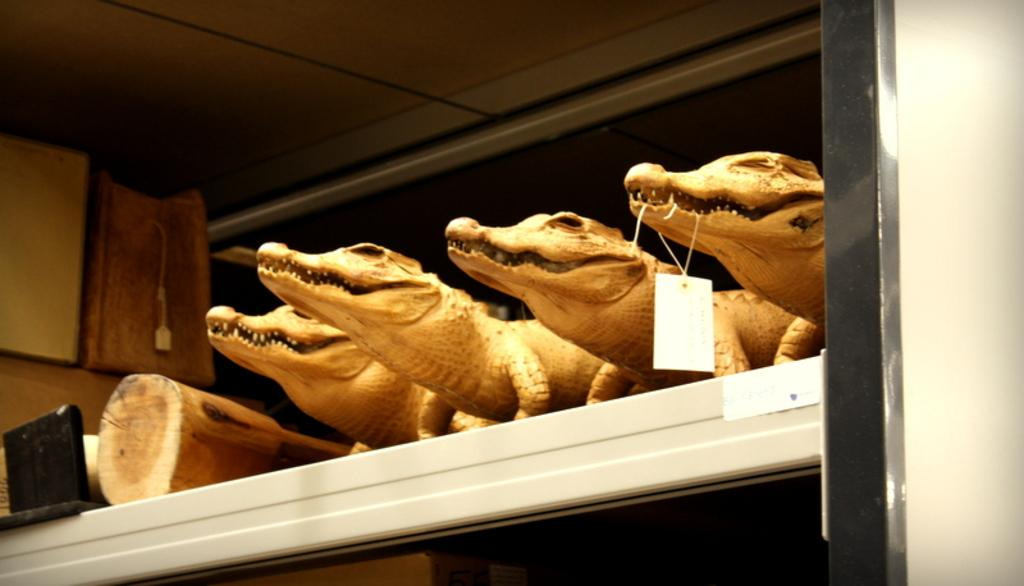What type of animals can be seen in the image? There are depictions of crocodiles in the image. What material are the logs made of in the image? The logs in the image are made of wood. What can be found on the shelf in the image? There are objects on a shelf in the image. What type of hair can be seen on the crocodiles in the image? There is no hair present on the crocodiles in the image, as they are depicted as reptiles. 